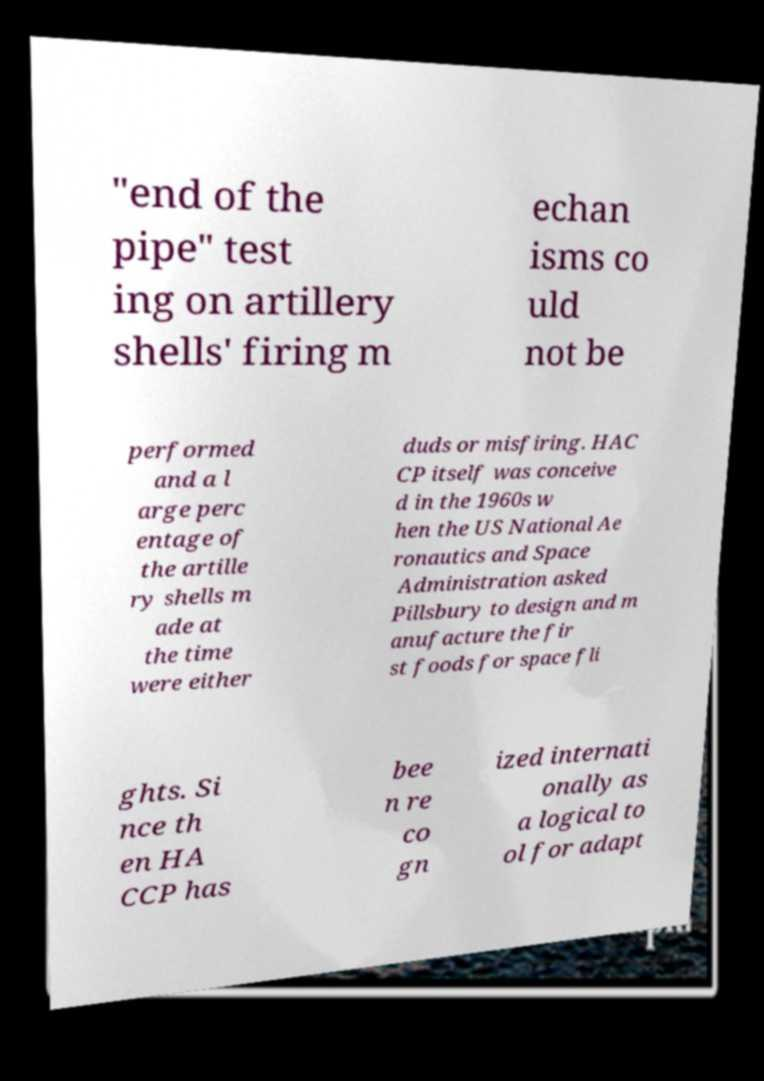What messages or text are displayed in this image? I need them in a readable, typed format. "end of the pipe" test ing on artillery shells' firing m echan isms co uld not be performed and a l arge perc entage of the artille ry shells m ade at the time were either duds or misfiring. HAC CP itself was conceive d in the 1960s w hen the US National Ae ronautics and Space Administration asked Pillsbury to design and m anufacture the fir st foods for space fli ghts. Si nce th en HA CCP has bee n re co gn ized internati onally as a logical to ol for adapt 